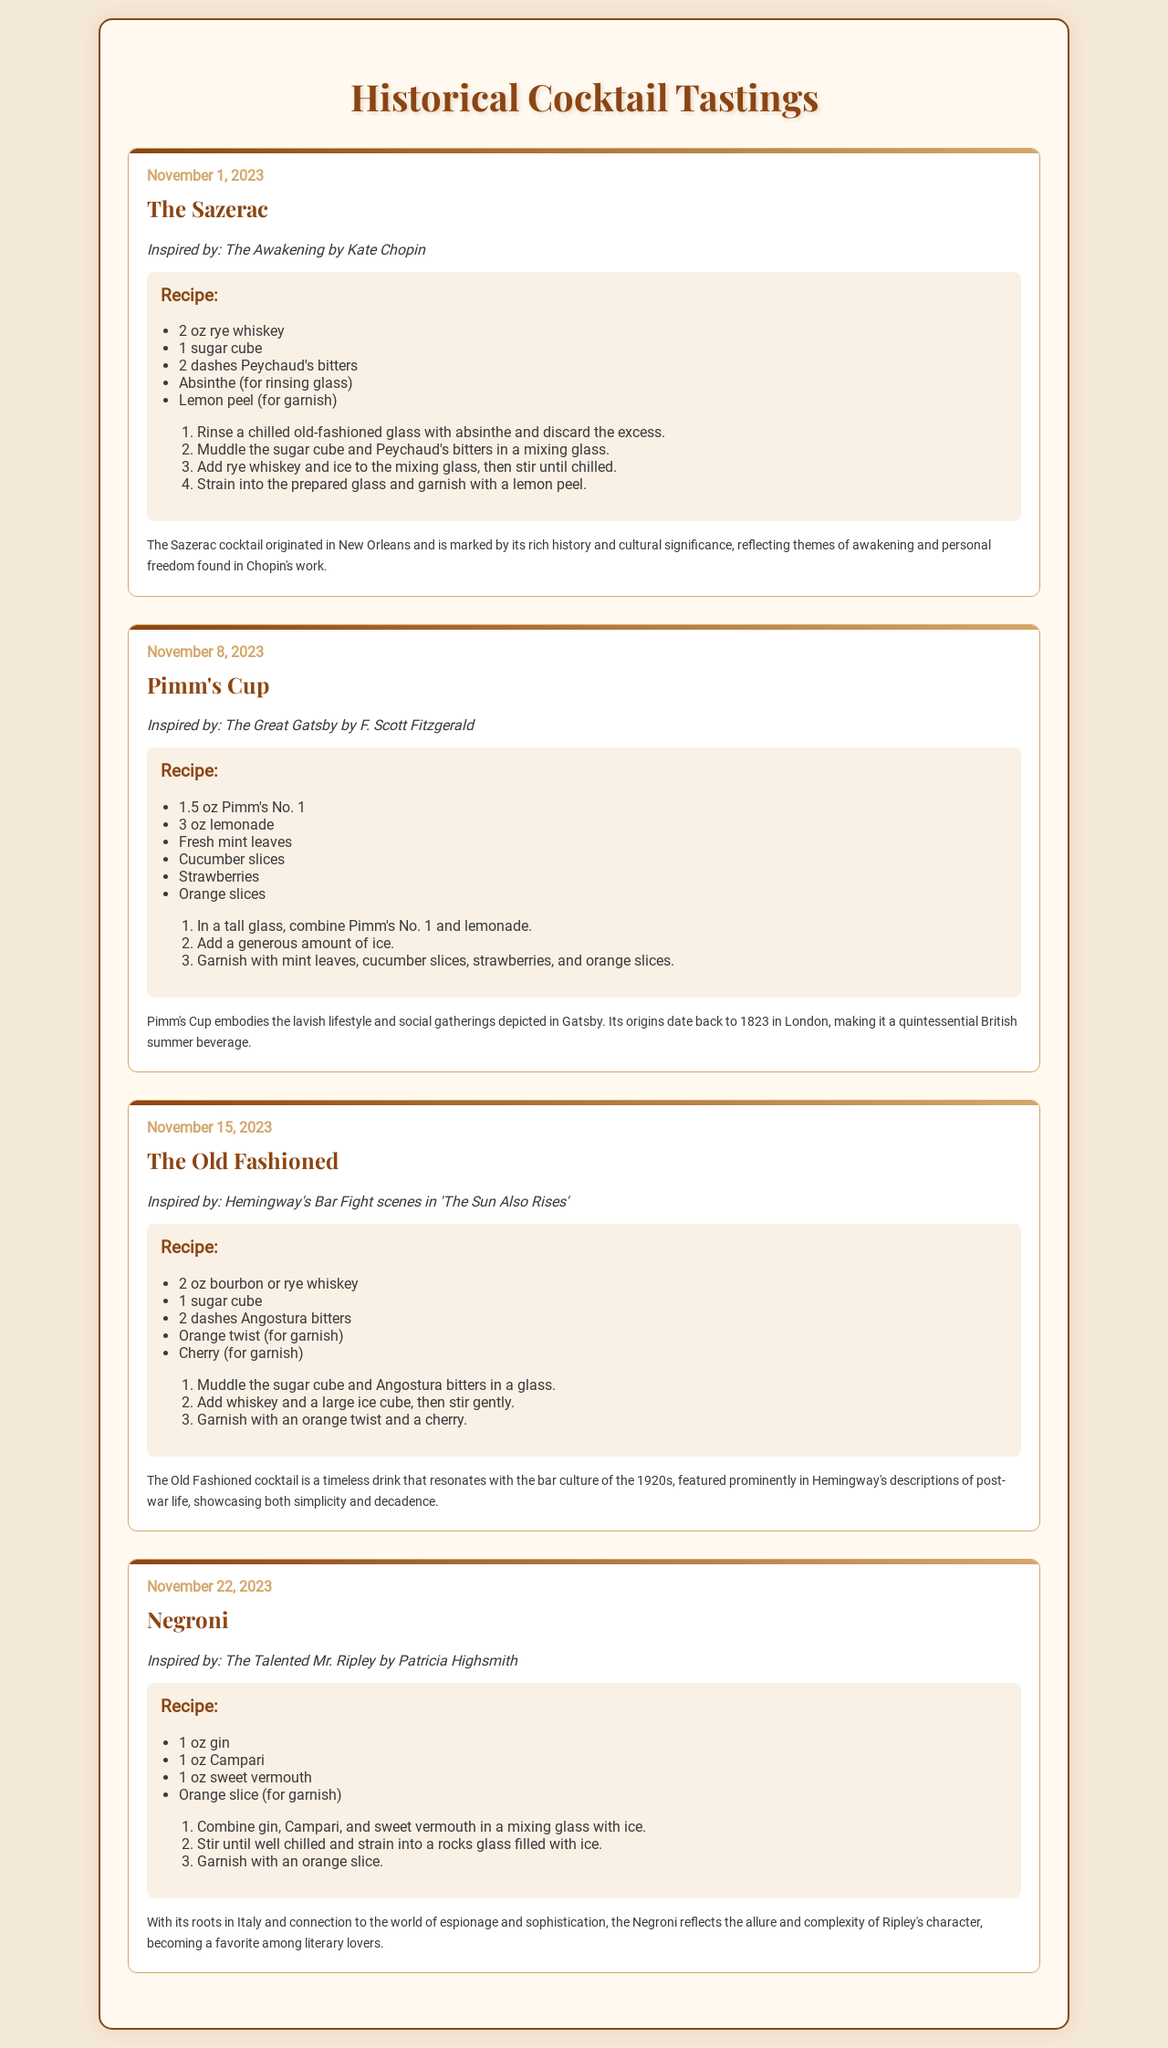What is the date of the Sazerac tasting? The date of the Sazerac tasting is indicated as November 1, 2023.
Answer: November 1, 2023 Which cocktail is inspired by The Great Gatsby? The document lists Pimm's Cup as the cocktail inspired by The Great Gatsby.
Answer: Pimm's Cup How many ingredients are in The Old Fashioned recipe? The Old Fashioned recipe includes five ingredients as listed in the document.
Answer: 5 What is the primary spirit used in the Negroni? The primary spirit used in the Negroni is gin, which is listed in the recipe section.
Answer: gin Which cocktail features lemon peel as a garnish? The Sazerac cocktail features lemon peel as a garnish according to the document.
Answer: Sazerac What literary theme is associated with The Sazerac cocktail? The Sazerac cocktail is associated with the themes of awakening and personal freedom from Chopin's work.
Answer: awakening and personal freedom Which cocktail has its origins in 1823? The Pimm's Cup has its origins dating back to 1823 in London.
Answer: Pimm's Cup What garnish is used for the Negroni? An orange slice is indicated as the garnish for the Negroni.
Answer: orange slice 